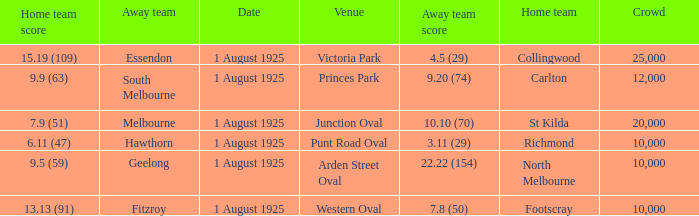When did the match take place that had a home team score of 7.9 (51)? 1 August 1925. 